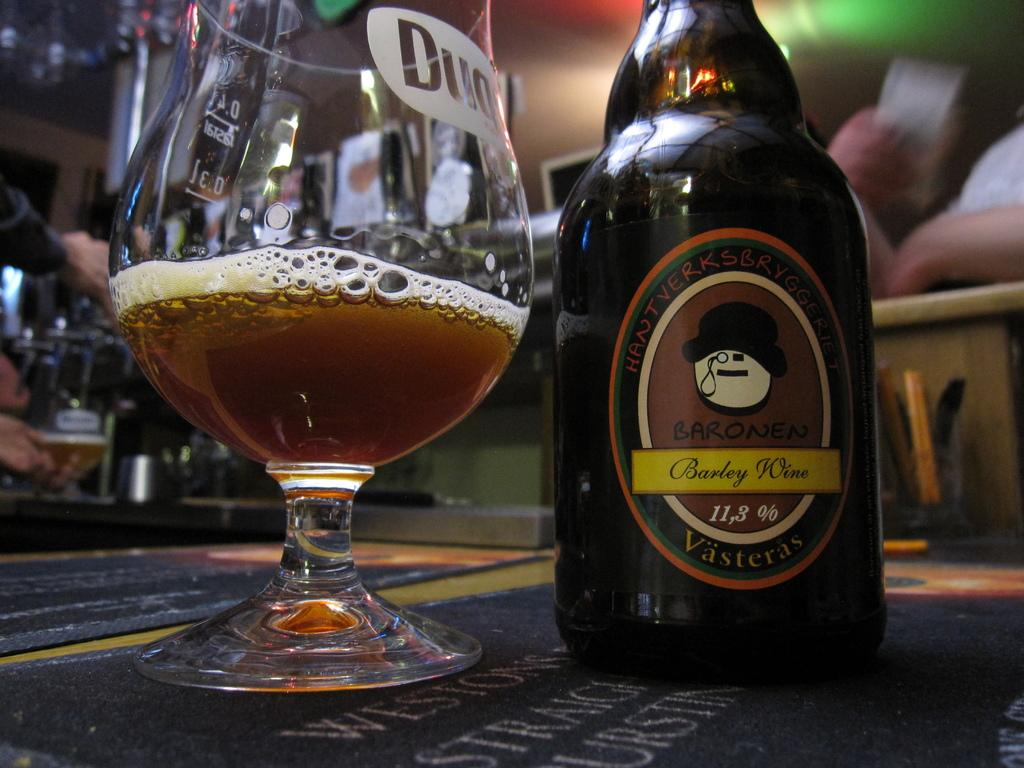<image>
Provide a brief description of the given image. Barley wine bottle is sitting on a table next to a glass slightly filled 